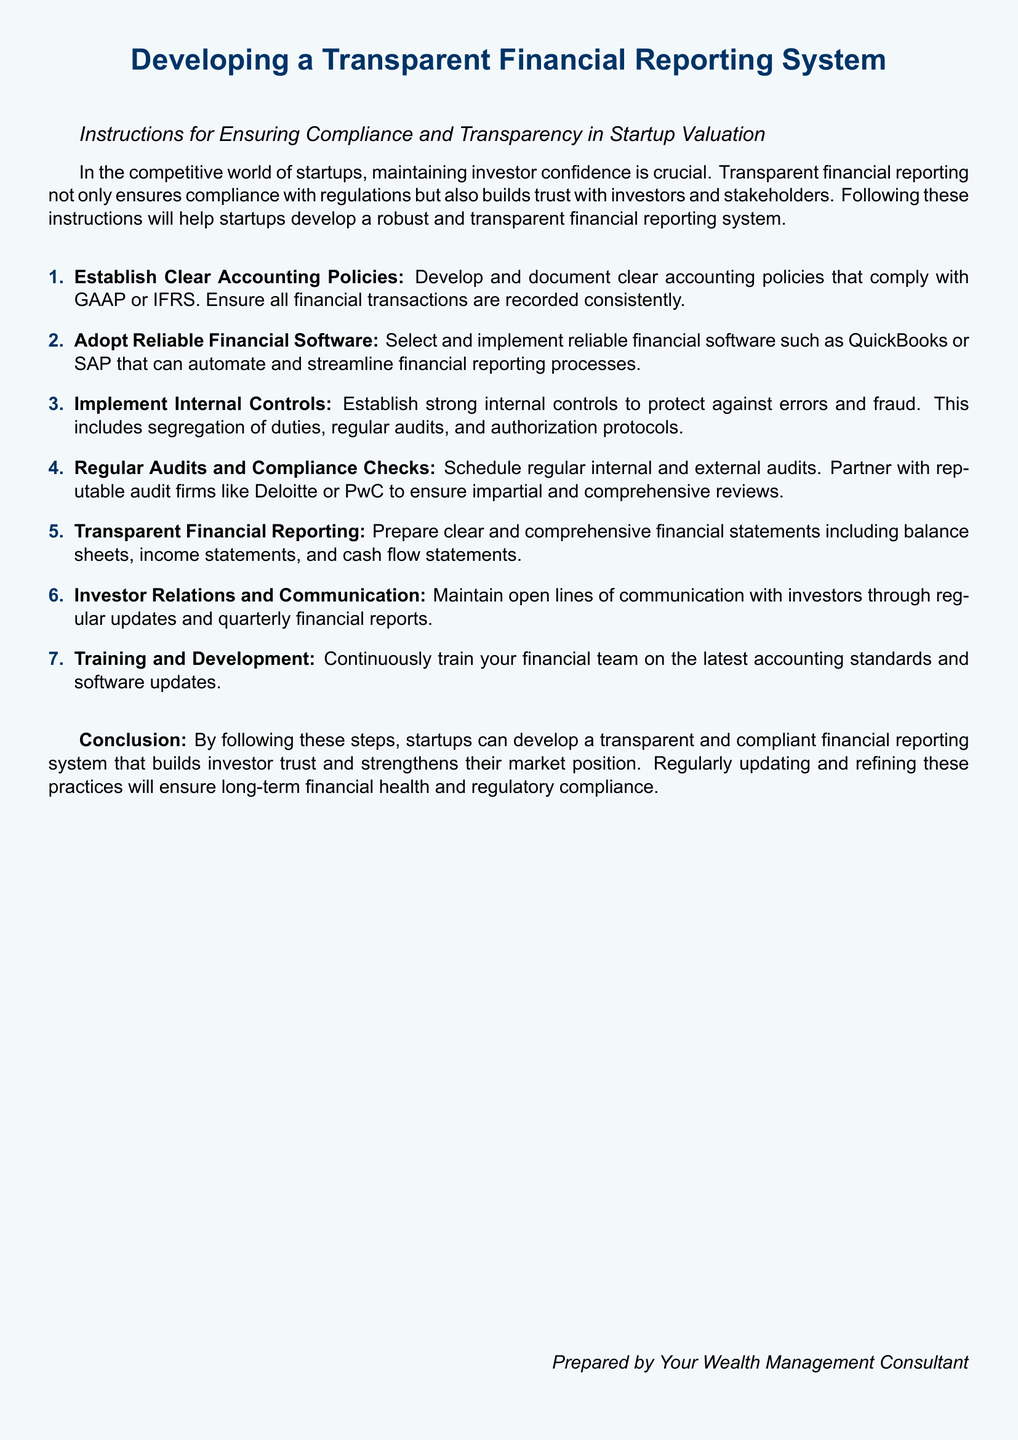What is the main topic of the document? The document discusses developing a transparent financial reporting system for startups.
Answer: Transparent financial reporting system How many main steps are included in the instructions? The instructions consist of seven main steps for ensuring compliance and transparency.
Answer: Seven Which accounting frameworks should startups comply with? Startups should comply with either GAAP or IFRS for their accounting policies.
Answer: GAAP or IFRS What type of software is recommended for financial reporting? Reliable financial software such as QuickBooks or SAP is recommended for automation.
Answer: QuickBooks or SAP Who should perform the regular audits? Regular audits should be performed by reputable audit firms like Deloitte or PwC.
Answer: Deloitte or PwC What is the purpose of maintaining open lines of communication with investors? Maintaining communication helps build trust and ensures stakeholders are informed about financial updates.
Answer: Build trust Which aspect of compliance involves ongoing education for the financial team? Training and development is necessary to keep the financial team updated with accounting standards and software.
Answer: Training and development What type of financial statements should be prepared? Clear and comprehensive financial statements must include balance sheets, income statements, and cash flow statements.
Answer: Balance sheets, income statements, cash flow statements 